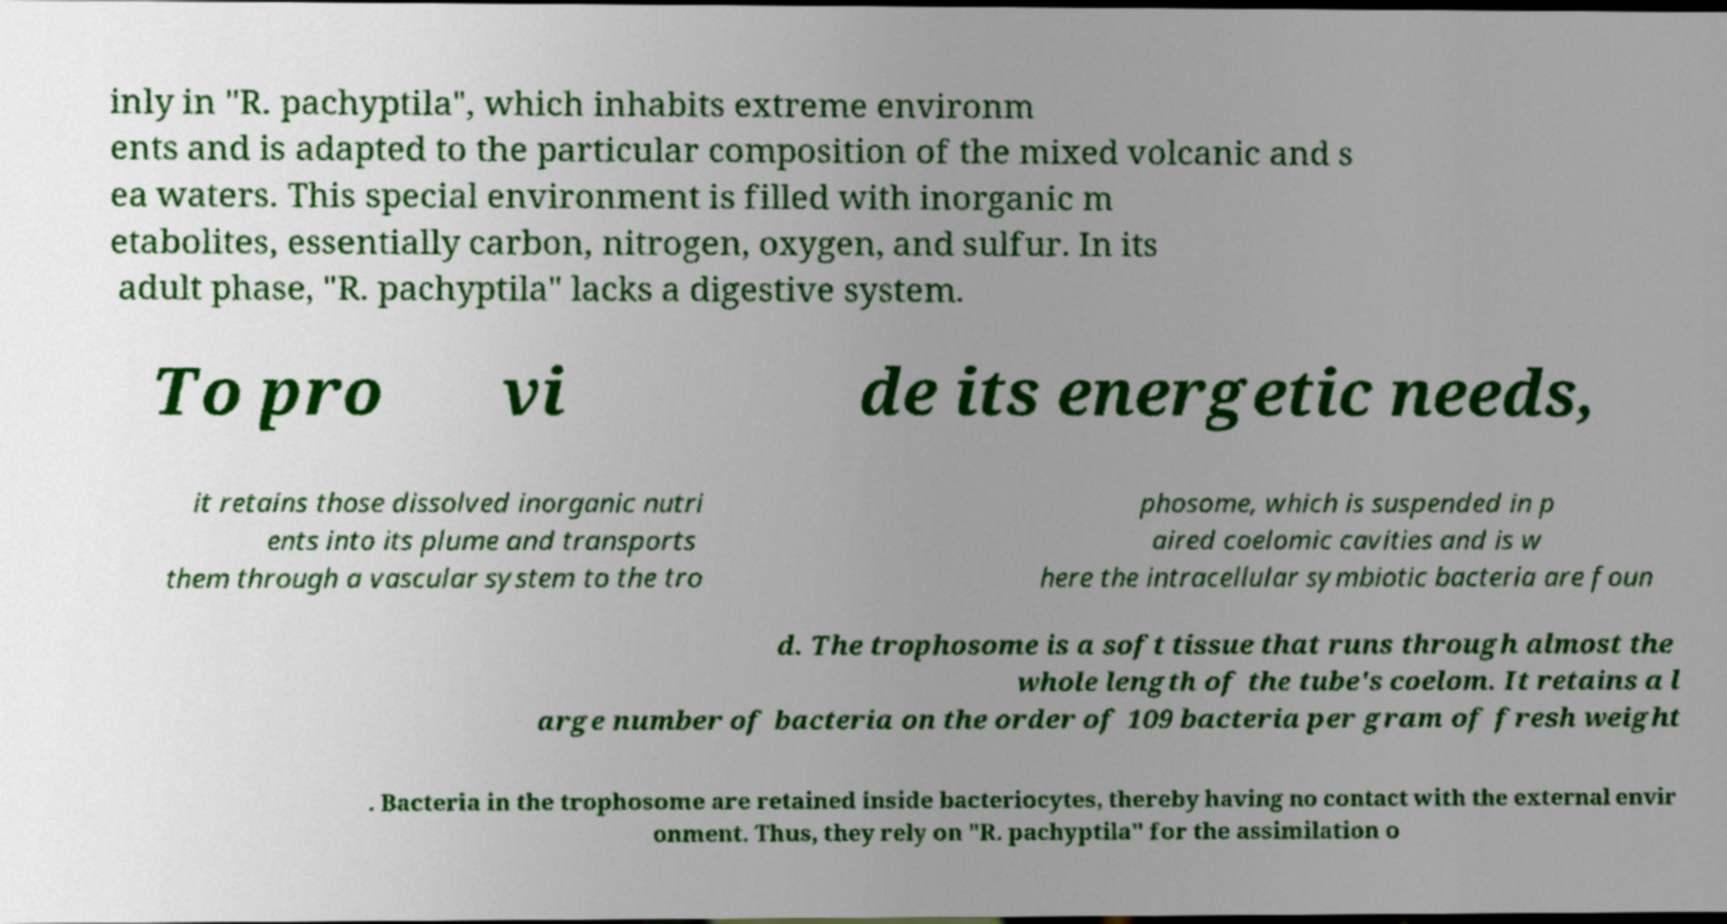Please identify and transcribe the text found in this image. inly in "R. pachyptila", which inhabits extreme environm ents and is adapted to the particular composition of the mixed volcanic and s ea waters. This special environment is filled with inorganic m etabolites, essentially carbon, nitrogen, oxygen, and sulfur. In its adult phase, "R. pachyptila" lacks a digestive system. To pro vi de its energetic needs, it retains those dissolved inorganic nutri ents into its plume and transports them through a vascular system to the tro phosome, which is suspended in p aired coelomic cavities and is w here the intracellular symbiotic bacteria are foun d. The trophosome is a soft tissue that runs through almost the whole length of the tube's coelom. It retains a l arge number of bacteria on the order of 109 bacteria per gram of fresh weight . Bacteria in the trophosome are retained inside bacteriocytes, thereby having no contact with the external envir onment. Thus, they rely on "R. pachyptila" for the assimilation o 